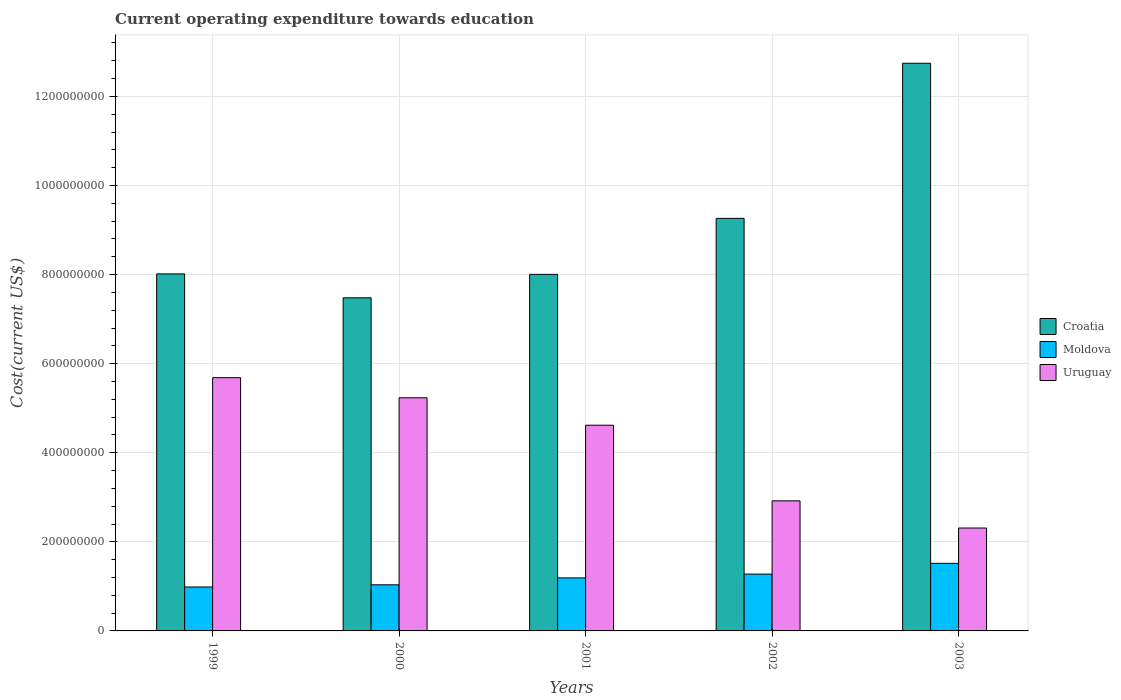How many groups of bars are there?
Provide a succinct answer. 5. Are the number of bars on each tick of the X-axis equal?
Make the answer very short. Yes. How many bars are there on the 2nd tick from the left?
Ensure brevity in your answer.  3. What is the label of the 5th group of bars from the left?
Your answer should be compact. 2003. In how many cases, is the number of bars for a given year not equal to the number of legend labels?
Offer a very short reply. 0. What is the expenditure towards education in Uruguay in 2003?
Your answer should be very brief. 2.31e+08. Across all years, what is the maximum expenditure towards education in Croatia?
Ensure brevity in your answer.  1.27e+09. Across all years, what is the minimum expenditure towards education in Croatia?
Offer a terse response. 7.48e+08. In which year was the expenditure towards education in Uruguay maximum?
Make the answer very short. 1999. In which year was the expenditure towards education in Moldova minimum?
Offer a terse response. 1999. What is the total expenditure towards education in Croatia in the graph?
Your answer should be very brief. 4.55e+09. What is the difference between the expenditure towards education in Croatia in 2001 and that in 2002?
Your answer should be very brief. -1.26e+08. What is the difference between the expenditure towards education in Uruguay in 2000 and the expenditure towards education in Moldova in 2001?
Provide a succinct answer. 4.04e+08. What is the average expenditure towards education in Moldova per year?
Your response must be concise. 1.20e+08. In the year 1999, what is the difference between the expenditure towards education in Croatia and expenditure towards education in Uruguay?
Make the answer very short. 2.33e+08. What is the ratio of the expenditure towards education in Croatia in 1999 to that in 2000?
Ensure brevity in your answer.  1.07. Is the difference between the expenditure towards education in Croatia in 2000 and 2001 greater than the difference between the expenditure towards education in Uruguay in 2000 and 2001?
Your answer should be very brief. No. What is the difference between the highest and the second highest expenditure towards education in Uruguay?
Keep it short and to the point. 4.51e+07. What is the difference between the highest and the lowest expenditure towards education in Croatia?
Your response must be concise. 5.27e+08. What does the 2nd bar from the left in 2002 represents?
Ensure brevity in your answer.  Moldova. What does the 3rd bar from the right in 2003 represents?
Your answer should be very brief. Croatia. Is it the case that in every year, the sum of the expenditure towards education in Uruguay and expenditure towards education in Moldova is greater than the expenditure towards education in Croatia?
Your answer should be compact. No. What is the difference between two consecutive major ticks on the Y-axis?
Offer a very short reply. 2.00e+08. Are the values on the major ticks of Y-axis written in scientific E-notation?
Provide a succinct answer. No. How many legend labels are there?
Give a very brief answer. 3. What is the title of the graph?
Offer a very short reply. Current operating expenditure towards education. What is the label or title of the Y-axis?
Ensure brevity in your answer.  Cost(current US$). What is the Cost(current US$) in Croatia in 1999?
Give a very brief answer. 8.02e+08. What is the Cost(current US$) in Moldova in 1999?
Your response must be concise. 9.86e+07. What is the Cost(current US$) of Uruguay in 1999?
Your response must be concise. 5.69e+08. What is the Cost(current US$) of Croatia in 2000?
Provide a short and direct response. 7.48e+08. What is the Cost(current US$) in Moldova in 2000?
Give a very brief answer. 1.03e+08. What is the Cost(current US$) in Uruguay in 2000?
Provide a short and direct response. 5.23e+08. What is the Cost(current US$) of Croatia in 2001?
Provide a short and direct response. 8.00e+08. What is the Cost(current US$) of Moldova in 2001?
Provide a short and direct response. 1.19e+08. What is the Cost(current US$) of Uruguay in 2001?
Your answer should be very brief. 4.62e+08. What is the Cost(current US$) of Croatia in 2002?
Your answer should be very brief. 9.26e+08. What is the Cost(current US$) of Moldova in 2002?
Your answer should be compact. 1.28e+08. What is the Cost(current US$) in Uruguay in 2002?
Give a very brief answer. 2.92e+08. What is the Cost(current US$) of Croatia in 2003?
Provide a succinct answer. 1.27e+09. What is the Cost(current US$) of Moldova in 2003?
Offer a very short reply. 1.52e+08. What is the Cost(current US$) in Uruguay in 2003?
Ensure brevity in your answer.  2.31e+08. Across all years, what is the maximum Cost(current US$) in Croatia?
Keep it short and to the point. 1.27e+09. Across all years, what is the maximum Cost(current US$) of Moldova?
Offer a terse response. 1.52e+08. Across all years, what is the maximum Cost(current US$) in Uruguay?
Your answer should be compact. 5.69e+08. Across all years, what is the minimum Cost(current US$) of Croatia?
Provide a short and direct response. 7.48e+08. Across all years, what is the minimum Cost(current US$) in Moldova?
Make the answer very short. 9.86e+07. Across all years, what is the minimum Cost(current US$) in Uruguay?
Offer a very short reply. 2.31e+08. What is the total Cost(current US$) of Croatia in the graph?
Provide a succinct answer. 4.55e+09. What is the total Cost(current US$) in Moldova in the graph?
Provide a succinct answer. 6.00e+08. What is the total Cost(current US$) of Uruguay in the graph?
Your answer should be compact. 2.08e+09. What is the difference between the Cost(current US$) in Croatia in 1999 and that in 2000?
Keep it short and to the point. 5.37e+07. What is the difference between the Cost(current US$) in Moldova in 1999 and that in 2000?
Provide a succinct answer. -4.87e+06. What is the difference between the Cost(current US$) in Uruguay in 1999 and that in 2000?
Ensure brevity in your answer.  4.51e+07. What is the difference between the Cost(current US$) of Croatia in 1999 and that in 2001?
Provide a short and direct response. 1.05e+06. What is the difference between the Cost(current US$) of Moldova in 1999 and that in 2001?
Offer a very short reply. -2.04e+07. What is the difference between the Cost(current US$) in Uruguay in 1999 and that in 2001?
Provide a short and direct response. 1.07e+08. What is the difference between the Cost(current US$) in Croatia in 1999 and that in 2002?
Ensure brevity in your answer.  -1.25e+08. What is the difference between the Cost(current US$) in Moldova in 1999 and that in 2002?
Provide a short and direct response. -2.89e+07. What is the difference between the Cost(current US$) of Uruguay in 1999 and that in 2002?
Your answer should be compact. 2.77e+08. What is the difference between the Cost(current US$) in Croatia in 1999 and that in 2003?
Your response must be concise. -4.73e+08. What is the difference between the Cost(current US$) of Moldova in 1999 and that in 2003?
Keep it short and to the point. -5.31e+07. What is the difference between the Cost(current US$) of Uruguay in 1999 and that in 2003?
Make the answer very short. 3.38e+08. What is the difference between the Cost(current US$) of Croatia in 2000 and that in 2001?
Provide a succinct answer. -5.26e+07. What is the difference between the Cost(current US$) of Moldova in 2000 and that in 2001?
Ensure brevity in your answer.  -1.55e+07. What is the difference between the Cost(current US$) in Uruguay in 2000 and that in 2001?
Ensure brevity in your answer.  6.16e+07. What is the difference between the Cost(current US$) of Croatia in 2000 and that in 2002?
Offer a very short reply. -1.78e+08. What is the difference between the Cost(current US$) in Moldova in 2000 and that in 2002?
Give a very brief answer. -2.41e+07. What is the difference between the Cost(current US$) in Uruguay in 2000 and that in 2002?
Your response must be concise. 2.31e+08. What is the difference between the Cost(current US$) in Croatia in 2000 and that in 2003?
Offer a terse response. -5.27e+08. What is the difference between the Cost(current US$) of Moldova in 2000 and that in 2003?
Make the answer very short. -4.82e+07. What is the difference between the Cost(current US$) of Uruguay in 2000 and that in 2003?
Your answer should be compact. 2.92e+08. What is the difference between the Cost(current US$) of Croatia in 2001 and that in 2002?
Offer a terse response. -1.26e+08. What is the difference between the Cost(current US$) in Moldova in 2001 and that in 2002?
Provide a short and direct response. -8.53e+06. What is the difference between the Cost(current US$) in Uruguay in 2001 and that in 2002?
Your answer should be compact. 1.70e+08. What is the difference between the Cost(current US$) in Croatia in 2001 and that in 2003?
Offer a very short reply. -4.74e+08. What is the difference between the Cost(current US$) in Moldova in 2001 and that in 2003?
Provide a succinct answer. -3.27e+07. What is the difference between the Cost(current US$) of Uruguay in 2001 and that in 2003?
Provide a short and direct response. 2.31e+08. What is the difference between the Cost(current US$) in Croatia in 2002 and that in 2003?
Offer a very short reply. -3.48e+08. What is the difference between the Cost(current US$) of Moldova in 2002 and that in 2003?
Provide a short and direct response. -2.42e+07. What is the difference between the Cost(current US$) in Uruguay in 2002 and that in 2003?
Your answer should be very brief. 6.10e+07. What is the difference between the Cost(current US$) in Croatia in 1999 and the Cost(current US$) in Moldova in 2000?
Your answer should be compact. 6.98e+08. What is the difference between the Cost(current US$) in Croatia in 1999 and the Cost(current US$) in Uruguay in 2000?
Your answer should be compact. 2.78e+08. What is the difference between the Cost(current US$) of Moldova in 1999 and the Cost(current US$) of Uruguay in 2000?
Your answer should be very brief. -4.25e+08. What is the difference between the Cost(current US$) in Croatia in 1999 and the Cost(current US$) in Moldova in 2001?
Offer a terse response. 6.83e+08. What is the difference between the Cost(current US$) in Croatia in 1999 and the Cost(current US$) in Uruguay in 2001?
Keep it short and to the point. 3.40e+08. What is the difference between the Cost(current US$) in Moldova in 1999 and the Cost(current US$) in Uruguay in 2001?
Offer a terse response. -3.63e+08. What is the difference between the Cost(current US$) in Croatia in 1999 and the Cost(current US$) in Moldova in 2002?
Give a very brief answer. 6.74e+08. What is the difference between the Cost(current US$) in Croatia in 1999 and the Cost(current US$) in Uruguay in 2002?
Your answer should be compact. 5.10e+08. What is the difference between the Cost(current US$) of Moldova in 1999 and the Cost(current US$) of Uruguay in 2002?
Make the answer very short. -1.93e+08. What is the difference between the Cost(current US$) of Croatia in 1999 and the Cost(current US$) of Moldova in 2003?
Offer a terse response. 6.50e+08. What is the difference between the Cost(current US$) of Croatia in 1999 and the Cost(current US$) of Uruguay in 2003?
Provide a succinct answer. 5.71e+08. What is the difference between the Cost(current US$) of Moldova in 1999 and the Cost(current US$) of Uruguay in 2003?
Provide a short and direct response. -1.32e+08. What is the difference between the Cost(current US$) of Croatia in 2000 and the Cost(current US$) of Moldova in 2001?
Offer a terse response. 6.29e+08. What is the difference between the Cost(current US$) of Croatia in 2000 and the Cost(current US$) of Uruguay in 2001?
Provide a short and direct response. 2.86e+08. What is the difference between the Cost(current US$) of Moldova in 2000 and the Cost(current US$) of Uruguay in 2001?
Your response must be concise. -3.58e+08. What is the difference between the Cost(current US$) in Croatia in 2000 and the Cost(current US$) in Moldova in 2002?
Provide a succinct answer. 6.20e+08. What is the difference between the Cost(current US$) in Croatia in 2000 and the Cost(current US$) in Uruguay in 2002?
Keep it short and to the point. 4.56e+08. What is the difference between the Cost(current US$) in Moldova in 2000 and the Cost(current US$) in Uruguay in 2002?
Offer a terse response. -1.89e+08. What is the difference between the Cost(current US$) of Croatia in 2000 and the Cost(current US$) of Moldova in 2003?
Give a very brief answer. 5.96e+08. What is the difference between the Cost(current US$) in Croatia in 2000 and the Cost(current US$) in Uruguay in 2003?
Make the answer very short. 5.17e+08. What is the difference between the Cost(current US$) in Moldova in 2000 and the Cost(current US$) in Uruguay in 2003?
Offer a terse response. -1.28e+08. What is the difference between the Cost(current US$) of Croatia in 2001 and the Cost(current US$) of Moldova in 2002?
Offer a terse response. 6.73e+08. What is the difference between the Cost(current US$) of Croatia in 2001 and the Cost(current US$) of Uruguay in 2002?
Offer a terse response. 5.08e+08. What is the difference between the Cost(current US$) of Moldova in 2001 and the Cost(current US$) of Uruguay in 2002?
Your answer should be very brief. -1.73e+08. What is the difference between the Cost(current US$) in Croatia in 2001 and the Cost(current US$) in Moldova in 2003?
Make the answer very short. 6.49e+08. What is the difference between the Cost(current US$) of Croatia in 2001 and the Cost(current US$) of Uruguay in 2003?
Your answer should be compact. 5.70e+08. What is the difference between the Cost(current US$) of Moldova in 2001 and the Cost(current US$) of Uruguay in 2003?
Provide a short and direct response. -1.12e+08. What is the difference between the Cost(current US$) of Croatia in 2002 and the Cost(current US$) of Moldova in 2003?
Offer a very short reply. 7.74e+08. What is the difference between the Cost(current US$) in Croatia in 2002 and the Cost(current US$) in Uruguay in 2003?
Provide a succinct answer. 6.95e+08. What is the difference between the Cost(current US$) of Moldova in 2002 and the Cost(current US$) of Uruguay in 2003?
Your response must be concise. -1.03e+08. What is the average Cost(current US$) in Croatia per year?
Your response must be concise. 9.10e+08. What is the average Cost(current US$) in Moldova per year?
Provide a succinct answer. 1.20e+08. What is the average Cost(current US$) in Uruguay per year?
Ensure brevity in your answer.  4.15e+08. In the year 1999, what is the difference between the Cost(current US$) of Croatia and Cost(current US$) of Moldova?
Make the answer very short. 7.03e+08. In the year 1999, what is the difference between the Cost(current US$) in Croatia and Cost(current US$) in Uruguay?
Offer a very short reply. 2.33e+08. In the year 1999, what is the difference between the Cost(current US$) in Moldova and Cost(current US$) in Uruguay?
Give a very brief answer. -4.70e+08. In the year 2000, what is the difference between the Cost(current US$) in Croatia and Cost(current US$) in Moldova?
Ensure brevity in your answer.  6.44e+08. In the year 2000, what is the difference between the Cost(current US$) of Croatia and Cost(current US$) of Uruguay?
Your answer should be compact. 2.24e+08. In the year 2000, what is the difference between the Cost(current US$) in Moldova and Cost(current US$) in Uruguay?
Ensure brevity in your answer.  -4.20e+08. In the year 2001, what is the difference between the Cost(current US$) of Croatia and Cost(current US$) of Moldova?
Provide a short and direct response. 6.81e+08. In the year 2001, what is the difference between the Cost(current US$) of Croatia and Cost(current US$) of Uruguay?
Provide a succinct answer. 3.39e+08. In the year 2001, what is the difference between the Cost(current US$) in Moldova and Cost(current US$) in Uruguay?
Your answer should be compact. -3.43e+08. In the year 2002, what is the difference between the Cost(current US$) in Croatia and Cost(current US$) in Moldova?
Provide a succinct answer. 7.99e+08. In the year 2002, what is the difference between the Cost(current US$) of Croatia and Cost(current US$) of Uruguay?
Your answer should be compact. 6.34e+08. In the year 2002, what is the difference between the Cost(current US$) in Moldova and Cost(current US$) in Uruguay?
Your response must be concise. -1.64e+08. In the year 2003, what is the difference between the Cost(current US$) of Croatia and Cost(current US$) of Moldova?
Give a very brief answer. 1.12e+09. In the year 2003, what is the difference between the Cost(current US$) of Croatia and Cost(current US$) of Uruguay?
Ensure brevity in your answer.  1.04e+09. In the year 2003, what is the difference between the Cost(current US$) in Moldova and Cost(current US$) in Uruguay?
Your response must be concise. -7.93e+07. What is the ratio of the Cost(current US$) of Croatia in 1999 to that in 2000?
Offer a very short reply. 1.07. What is the ratio of the Cost(current US$) of Moldova in 1999 to that in 2000?
Your answer should be compact. 0.95. What is the ratio of the Cost(current US$) of Uruguay in 1999 to that in 2000?
Provide a short and direct response. 1.09. What is the ratio of the Cost(current US$) of Croatia in 1999 to that in 2001?
Give a very brief answer. 1. What is the ratio of the Cost(current US$) in Moldova in 1999 to that in 2001?
Your answer should be very brief. 0.83. What is the ratio of the Cost(current US$) of Uruguay in 1999 to that in 2001?
Provide a succinct answer. 1.23. What is the ratio of the Cost(current US$) in Croatia in 1999 to that in 2002?
Your answer should be very brief. 0.87. What is the ratio of the Cost(current US$) of Moldova in 1999 to that in 2002?
Offer a very short reply. 0.77. What is the ratio of the Cost(current US$) of Uruguay in 1999 to that in 2002?
Give a very brief answer. 1.95. What is the ratio of the Cost(current US$) of Croatia in 1999 to that in 2003?
Keep it short and to the point. 0.63. What is the ratio of the Cost(current US$) in Moldova in 1999 to that in 2003?
Make the answer very short. 0.65. What is the ratio of the Cost(current US$) of Uruguay in 1999 to that in 2003?
Your answer should be very brief. 2.46. What is the ratio of the Cost(current US$) of Croatia in 2000 to that in 2001?
Ensure brevity in your answer.  0.93. What is the ratio of the Cost(current US$) of Moldova in 2000 to that in 2001?
Give a very brief answer. 0.87. What is the ratio of the Cost(current US$) in Uruguay in 2000 to that in 2001?
Ensure brevity in your answer.  1.13. What is the ratio of the Cost(current US$) in Croatia in 2000 to that in 2002?
Offer a terse response. 0.81. What is the ratio of the Cost(current US$) of Moldova in 2000 to that in 2002?
Give a very brief answer. 0.81. What is the ratio of the Cost(current US$) in Uruguay in 2000 to that in 2002?
Provide a short and direct response. 1.79. What is the ratio of the Cost(current US$) of Croatia in 2000 to that in 2003?
Offer a very short reply. 0.59. What is the ratio of the Cost(current US$) in Moldova in 2000 to that in 2003?
Your answer should be very brief. 0.68. What is the ratio of the Cost(current US$) of Uruguay in 2000 to that in 2003?
Your answer should be very brief. 2.27. What is the ratio of the Cost(current US$) of Croatia in 2001 to that in 2002?
Your answer should be compact. 0.86. What is the ratio of the Cost(current US$) of Moldova in 2001 to that in 2002?
Keep it short and to the point. 0.93. What is the ratio of the Cost(current US$) in Uruguay in 2001 to that in 2002?
Provide a succinct answer. 1.58. What is the ratio of the Cost(current US$) in Croatia in 2001 to that in 2003?
Provide a short and direct response. 0.63. What is the ratio of the Cost(current US$) in Moldova in 2001 to that in 2003?
Offer a very short reply. 0.78. What is the ratio of the Cost(current US$) in Uruguay in 2001 to that in 2003?
Your response must be concise. 2. What is the ratio of the Cost(current US$) of Croatia in 2002 to that in 2003?
Give a very brief answer. 0.73. What is the ratio of the Cost(current US$) in Moldova in 2002 to that in 2003?
Keep it short and to the point. 0.84. What is the ratio of the Cost(current US$) in Uruguay in 2002 to that in 2003?
Your answer should be compact. 1.26. What is the difference between the highest and the second highest Cost(current US$) in Croatia?
Keep it short and to the point. 3.48e+08. What is the difference between the highest and the second highest Cost(current US$) of Moldova?
Offer a terse response. 2.42e+07. What is the difference between the highest and the second highest Cost(current US$) in Uruguay?
Offer a very short reply. 4.51e+07. What is the difference between the highest and the lowest Cost(current US$) of Croatia?
Provide a short and direct response. 5.27e+08. What is the difference between the highest and the lowest Cost(current US$) of Moldova?
Your answer should be very brief. 5.31e+07. What is the difference between the highest and the lowest Cost(current US$) in Uruguay?
Offer a very short reply. 3.38e+08. 